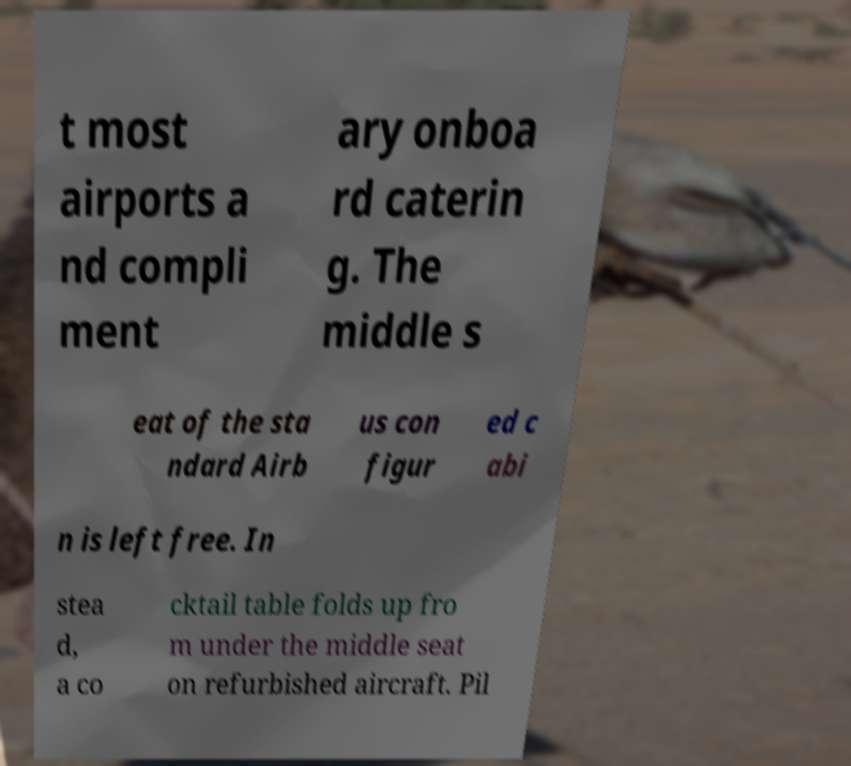Could you assist in decoding the text presented in this image and type it out clearly? t most airports a nd compli ment ary onboa rd caterin g. The middle s eat of the sta ndard Airb us con figur ed c abi n is left free. In stea d, a co cktail table folds up fro m under the middle seat on refurbished aircraft. Pil 